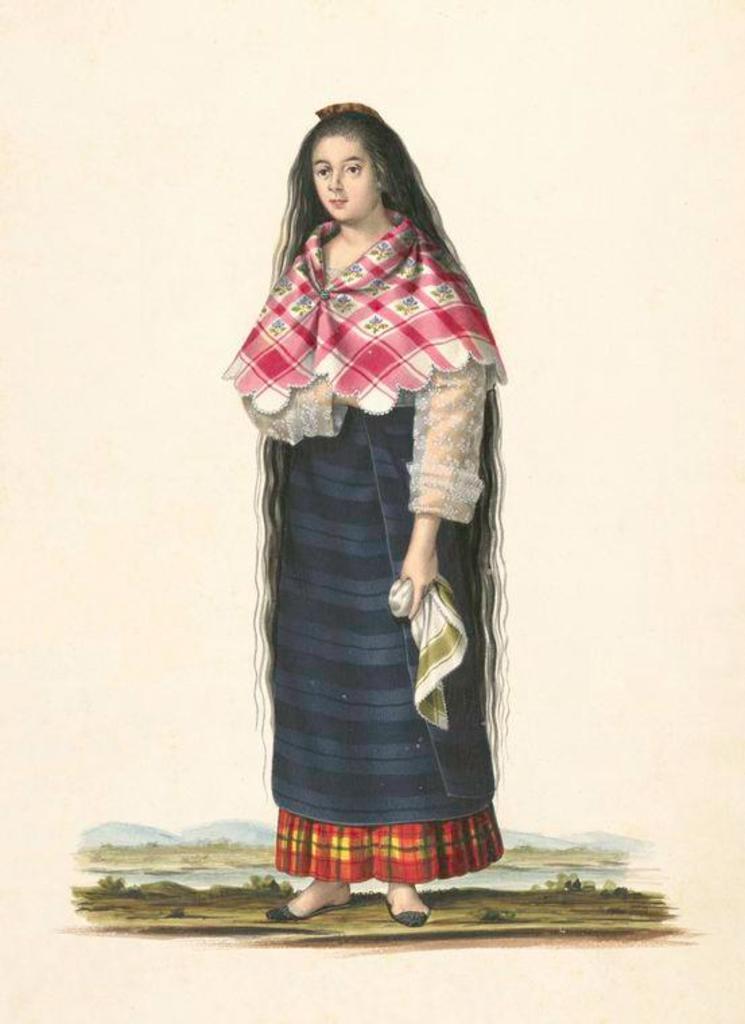Describe this image in one or two sentences. In this image we can see the picture with the painting. And there is a person standing and holding a cloth. At the bottom there are trees and water. And at the back it looks like a mountain. 